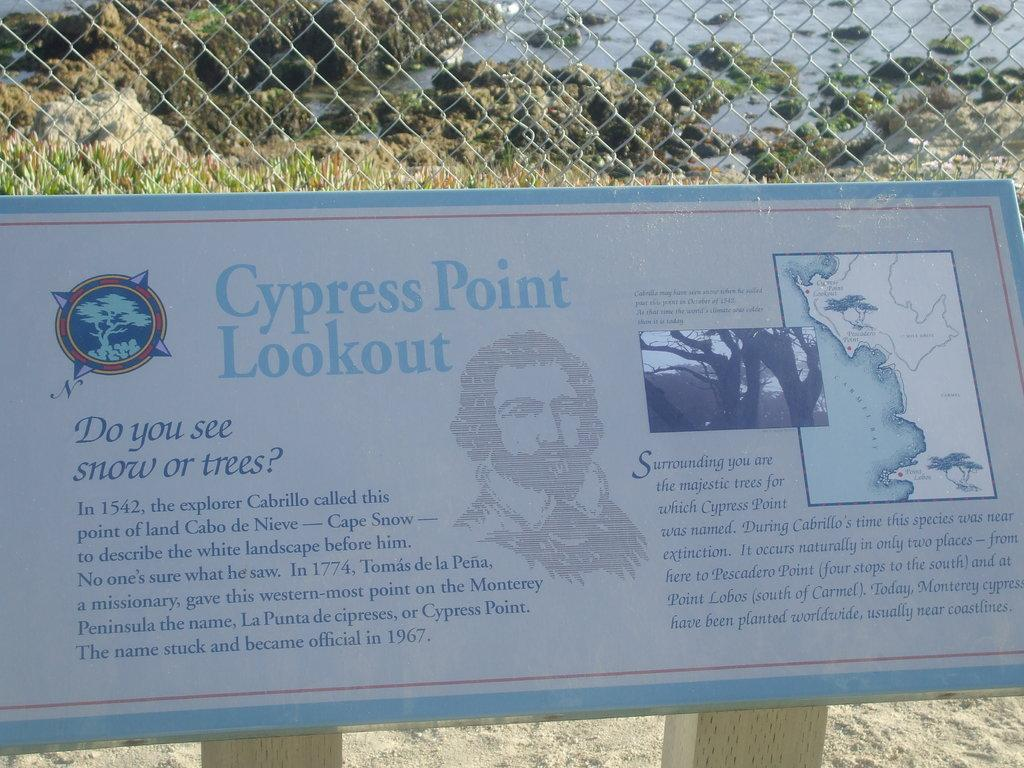What is written or displayed on the board in the image? There is a board with text in the image. What can be used for cooking in the image? There is a grill in the image that can be used for cooking. What type of surface is visible in the image? There is water and grass visible in the image. What is the texture of the ground at the bottom of the image? There is sand at the bottom of the image. How does the person in the image get a haircut while standing in the water? There is no person getting a haircut in the image; it only shows a board with text, a grill, water, grass, and sand. What type of nail is being hammered into the board in the image? There is no nail being hammered into the board in the image; it only shows a board with text. 